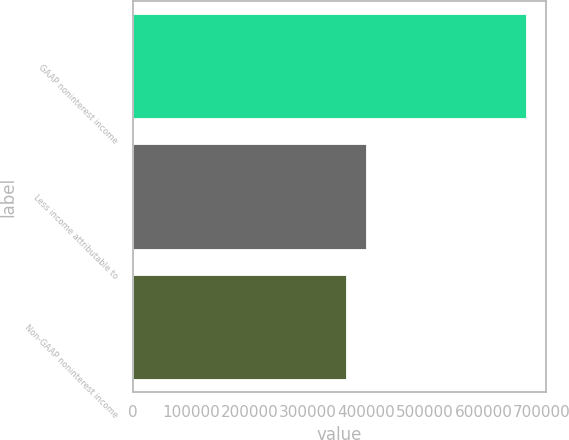Convert chart to OTSL. <chart><loc_0><loc_0><loc_500><loc_500><bar_chart><fcel>GAAP noninterest income<fcel>Less income attributable to<fcel>Non-GAAP noninterest income<nl><fcel>673206<fcel>398883<fcel>364592<nl></chart> 